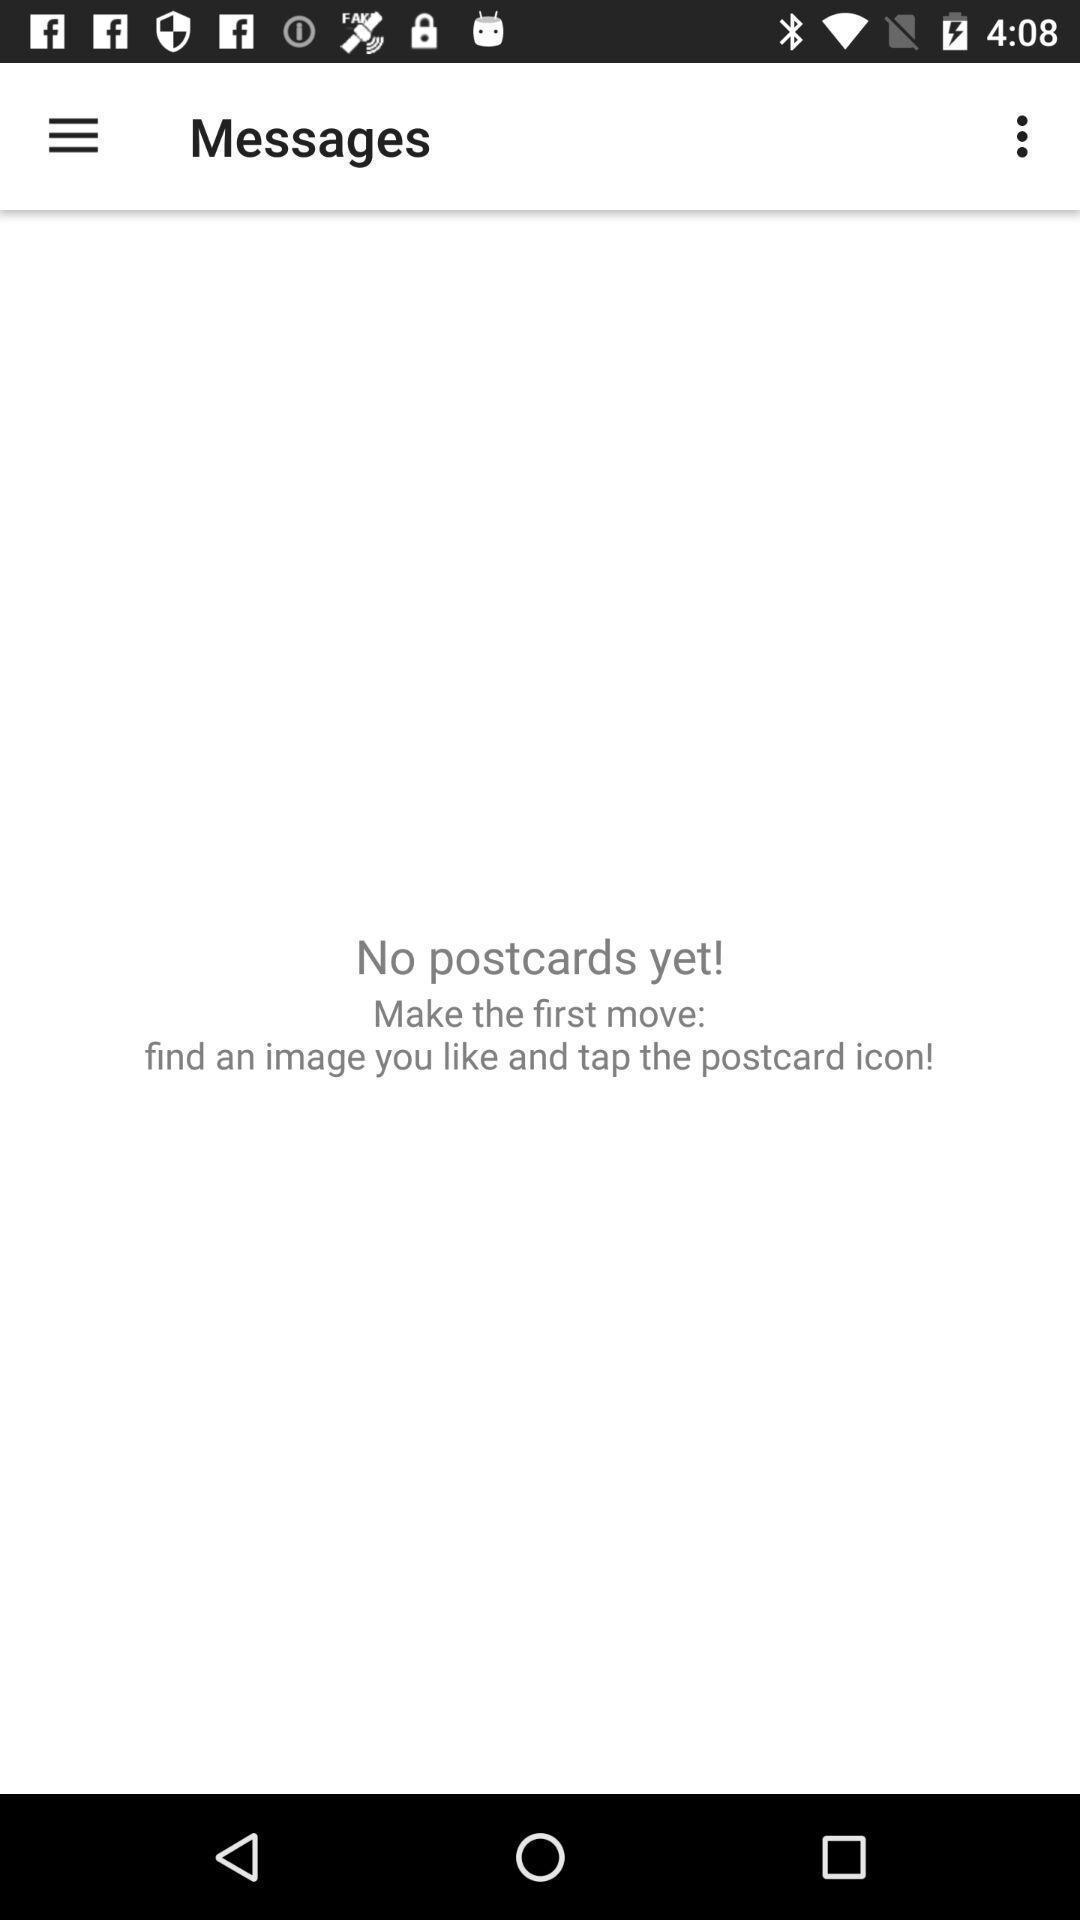Provide a detailed account of this screenshot. Page displaying result of received postcards in the app. 